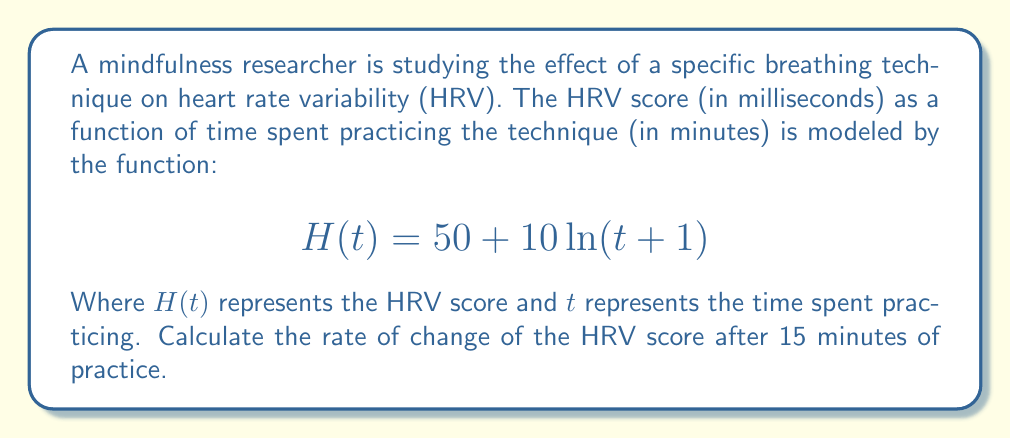Can you solve this math problem? To find the rate of change of the HRV score after 15 minutes of practice, we need to calculate the derivative of the function $H(t)$ and then evaluate it at $t=15$. Let's follow these steps:

1) The given function is:
   $$H(t) = 50 + 10\ln(t+1)$$

2) To find the derivative, we use the chain rule:
   $$H'(t) = 0 + 10 \cdot \frac{d}{dt}[\ln(t+1)]$$

3) The derivative of $\ln(x)$ is $\frac{1}{x}$, so:
   $$H'(t) = 10 \cdot \frac{1}{t+1}$$

4) Simplify:
   $$H'(t) = \frac{10}{t+1}$$

5) Now, we evaluate this at $t=15$:
   $$H'(15) = \frac{10}{15+1} = \frac{10}{16} = \frac{5}{8} = 0.625$$

Therefore, after 15 minutes of practice, the HRV score is changing at a rate of 0.625 milliseconds per minute.
Answer: $0.625$ ms/min 